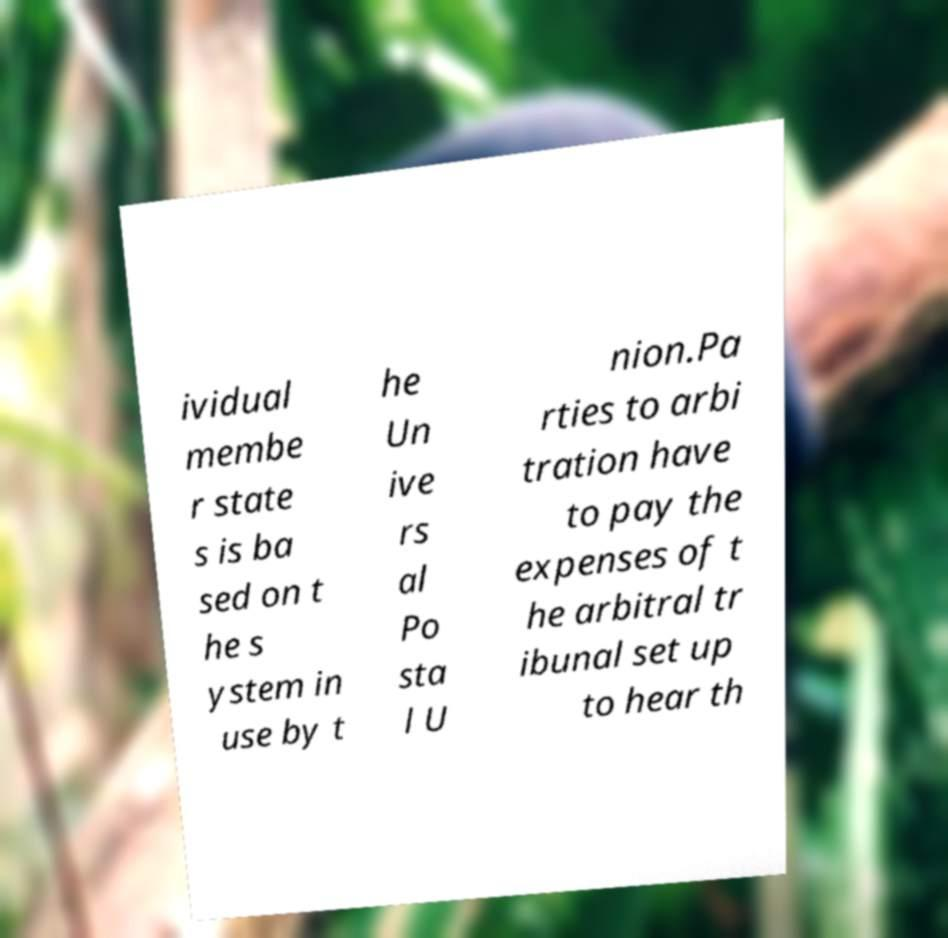Could you extract and type out the text from this image? ividual membe r state s is ba sed on t he s ystem in use by t he Un ive rs al Po sta l U nion.Pa rties to arbi tration have to pay the expenses of t he arbitral tr ibunal set up to hear th 